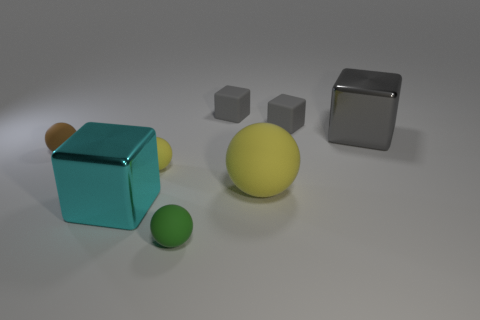Is there anything else that has the same material as the large yellow ball?
Give a very brief answer. Yes. There is a big object behind the ball left of the small yellow object; what shape is it?
Your answer should be very brief. Cube. The other large object that is the same material as the cyan object is what shape?
Provide a succinct answer. Cube. What number of other objects are there of the same shape as the cyan shiny object?
Offer a very short reply. 3. Do the matte thing in front of the cyan cube and the brown object have the same size?
Your answer should be very brief. Yes. Is the number of large gray shiny blocks that are on the left side of the brown object greater than the number of big blue shiny cubes?
Provide a short and direct response. No. What number of tiny spheres are left of the metal thing behind the small yellow matte object?
Provide a short and direct response. 3. Are there fewer tiny brown rubber balls on the right side of the large yellow ball than gray objects?
Your answer should be very brief. Yes. Are there any small matte spheres that are to the right of the large metallic cube that is on the left side of the yellow object that is to the right of the tiny green object?
Provide a succinct answer. Yes. Is the material of the large yellow ball the same as the tiny brown sphere that is behind the big cyan object?
Provide a short and direct response. Yes. 